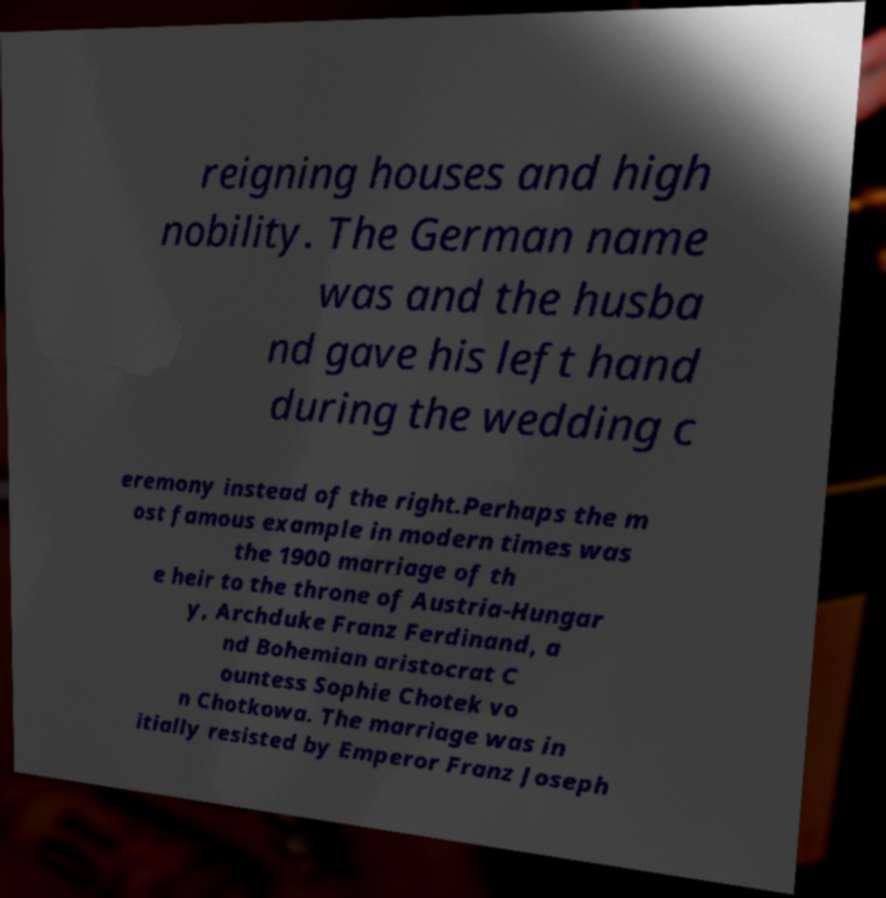Could you assist in decoding the text presented in this image and type it out clearly? reigning houses and high nobility. The German name was and the husba nd gave his left hand during the wedding c eremony instead of the right.Perhaps the m ost famous example in modern times was the 1900 marriage of th e heir to the throne of Austria-Hungar y, Archduke Franz Ferdinand, a nd Bohemian aristocrat C ountess Sophie Chotek vo n Chotkowa. The marriage was in itially resisted by Emperor Franz Joseph 